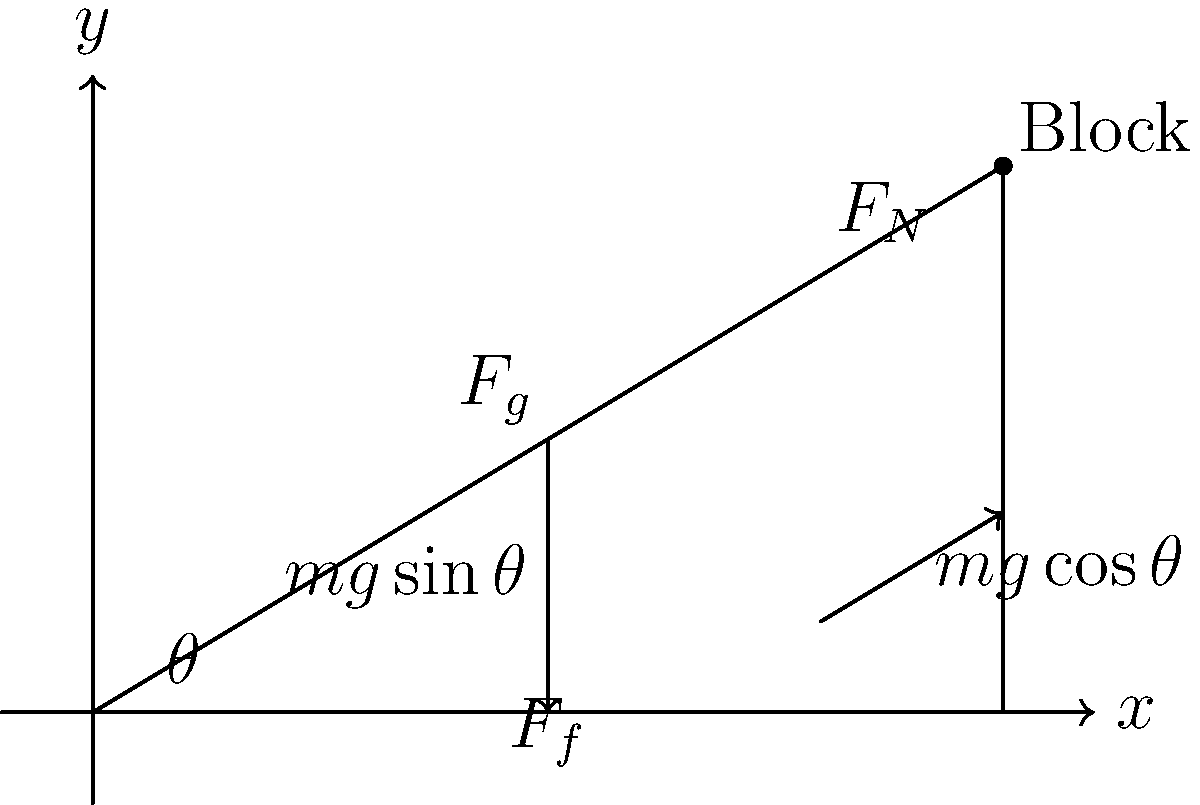As a detail-oriented product tester, you're evaluating the performance of a new friction-reducing coating on inclined surfaces. You set up an experiment with a block of mass $m = 2.0$ kg on an inclined plane with angle $\theta = 30°$. The coefficient of kinetic friction between the block and the surface is $\mu_k = 0.2$. Calculate the acceleration of the block down the plane, given that the gravitational acceleration $g = 9.8$ m/s². How would this result impact your recommendation for the coating's effectiveness? Let's approach this step-by-step:

1) First, we need to identify the forces acting on the block:
   - Gravitational force ($F_g = mg$)
   - Normal force ($F_N$)
   - Friction force ($F_f = \mu_k F_N$)

2) We can break down the gravitational force into components:
   - Parallel to the plane: $F_g \sin\theta = mg \sin\theta$
   - Perpendicular to the plane: $F_g \cos\theta = mg \cos\theta$

3) The normal force is equal to the perpendicular component of gravity:
   $F_N = mg \cos\theta$

4) Now we can calculate the friction force:
   $F_f = \mu_k F_N = \mu_k mg \cos\theta$

5) The net force down the plane is:
   $F_{net} = mg \sin\theta - \mu_k mg \cos\theta$

6) Using Newton's Second Law, $F = ma$, we can find the acceleration:
   $ma = mg \sin\theta - \mu_k mg \cos\theta$
   $a = g \sin\theta - \mu_k g \cos\theta$

7) Now let's plug in our values:
   $a = 9.8 \sin(30°) - 0.2 \times 9.8 \cos(30°)$
   $a = 9.8 \times 0.5 - 0.2 \times 9.8 \times 0.866$
   $a = 4.9 - 1.698 = 3.202$ m/s²

8) Interpreting the result:
   The block accelerates down the plane at 3.202 m/s². This indicates that the friction-reducing coating is somewhat effective, as the block is still accelerating despite the presence of friction. However, without a comparison to a non-coated surface, it's difficult to quantify the improvement. Further testing with varying angles and surface treatments would be recommended for a comprehensive evaluation.
Answer: 3.202 m/s²; moderately effective, further testing recommended 